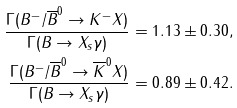<formula> <loc_0><loc_0><loc_500><loc_500>\frac { \Gamma ( B ^ { - } / \overline { B } ^ { 0 } \to K ^ { - } X ) } { \Gamma ( B \to X _ { s } \gamma ) } & = 1 . 1 3 \pm 0 . 3 0 , \\ \frac { \Gamma ( B ^ { - } / \overline { B } ^ { 0 } \to \overline { K } ^ { 0 } X ) } { \Gamma ( B \to X _ { s } \gamma ) } & = 0 . 8 9 \pm 0 . 4 2 .</formula> 